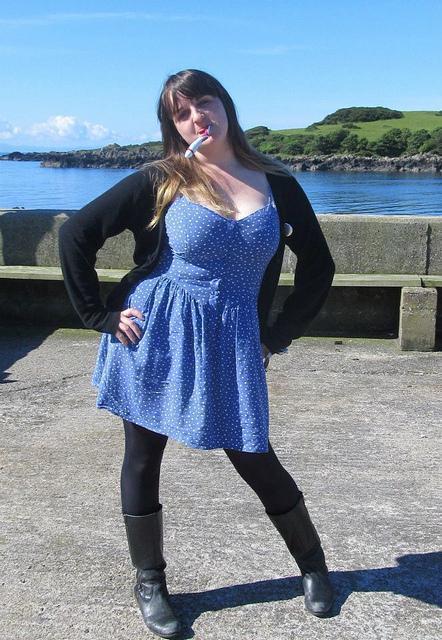To which direction of the woman is the sun located?
Answer the question by selecting the correct answer among the 4 following choices.
Options: Back, left, right, front. Left. 